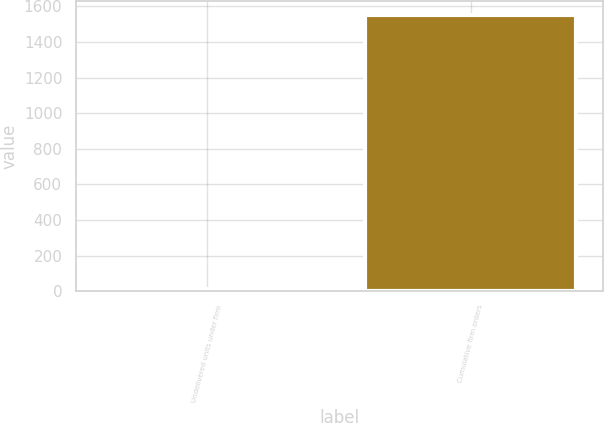<chart> <loc_0><loc_0><loc_500><loc_500><bar_chart><fcel>Undelivered units under firm<fcel>Cumulative firm orders<nl><fcel>12<fcel>1554<nl></chart> 